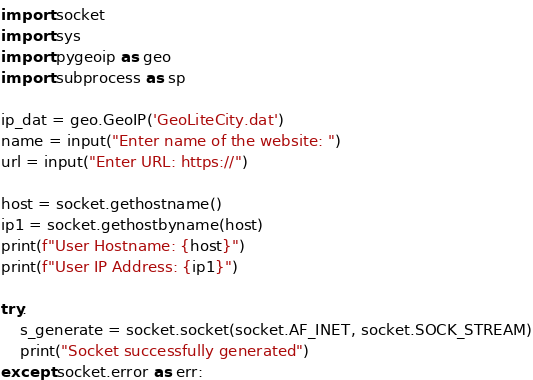<code> <loc_0><loc_0><loc_500><loc_500><_Python_>import socket
import sys
import pygeoip as geo
import subprocess as sp

ip_dat = geo.GeoIP('GeoLiteCity.dat')
name = input("Enter name of the website: ")
url = input("Enter URL: https://")

host = socket.gethostname()
ip1 = socket.gethostbyname(host)
print(f"User Hostname: {host}")
print(f"User IP Address: {ip1}")

try:
    s_generate = socket.socket(socket.AF_INET, socket.SOCK_STREAM)
    print("Socket successfully generated")
except socket.error as err:</code> 